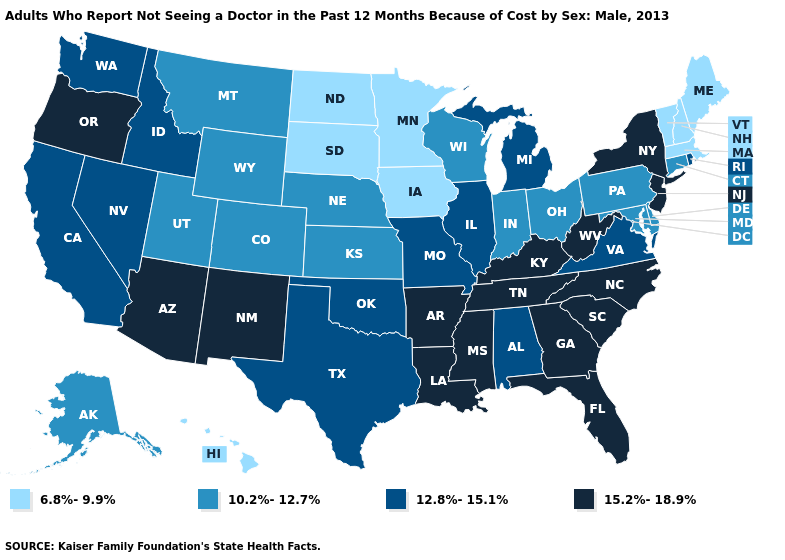Does New York have a higher value than North Carolina?
Keep it brief. No. What is the value of Colorado?
Write a very short answer. 10.2%-12.7%. What is the lowest value in the West?
Give a very brief answer. 6.8%-9.9%. Name the states that have a value in the range 10.2%-12.7%?
Quick response, please. Alaska, Colorado, Connecticut, Delaware, Indiana, Kansas, Maryland, Montana, Nebraska, Ohio, Pennsylvania, Utah, Wisconsin, Wyoming. What is the value of Arizona?
Answer briefly. 15.2%-18.9%. How many symbols are there in the legend?
Quick response, please. 4. Among the states that border Texas , which have the highest value?
Quick response, please. Arkansas, Louisiana, New Mexico. Does Vermont have the lowest value in the USA?
Answer briefly. Yes. Among the states that border Mississippi , does Alabama have the highest value?
Answer briefly. No. Does Utah have the lowest value in the West?
Keep it brief. No. Name the states that have a value in the range 12.8%-15.1%?
Write a very short answer. Alabama, California, Idaho, Illinois, Michigan, Missouri, Nevada, Oklahoma, Rhode Island, Texas, Virginia, Washington. Name the states that have a value in the range 10.2%-12.7%?
Short answer required. Alaska, Colorado, Connecticut, Delaware, Indiana, Kansas, Maryland, Montana, Nebraska, Ohio, Pennsylvania, Utah, Wisconsin, Wyoming. Is the legend a continuous bar?
Write a very short answer. No. What is the value of Kentucky?
Write a very short answer. 15.2%-18.9%. Name the states that have a value in the range 15.2%-18.9%?
Write a very short answer. Arizona, Arkansas, Florida, Georgia, Kentucky, Louisiana, Mississippi, New Jersey, New Mexico, New York, North Carolina, Oregon, South Carolina, Tennessee, West Virginia. 